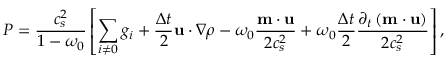<formula> <loc_0><loc_0><loc_500><loc_500>P = \frac { c _ { s } ^ { 2 } } { 1 - \omega _ { 0 } } \left [ \sum _ { i \neq 0 } g _ { i } + \frac { \Delta t } { 2 } u \cdot \nabla \rho - \omega _ { 0 } \frac { m \cdot u } { 2 c _ { s } ^ { 2 } } + \omega _ { 0 } \frac { \Delta t } { 2 } \frac { \partial _ { t } \left ( m \cdot u \right ) } { 2 c _ { s } ^ { 2 } } \right ] ,</formula> 